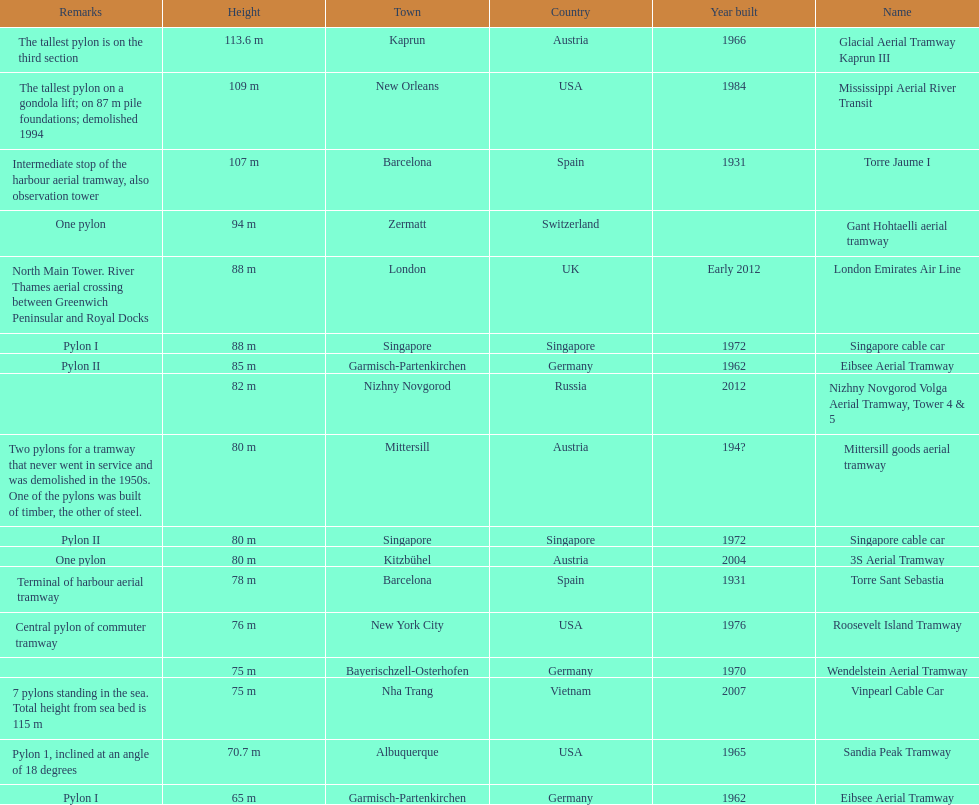What year was the last pylon in germany built? 1970. 